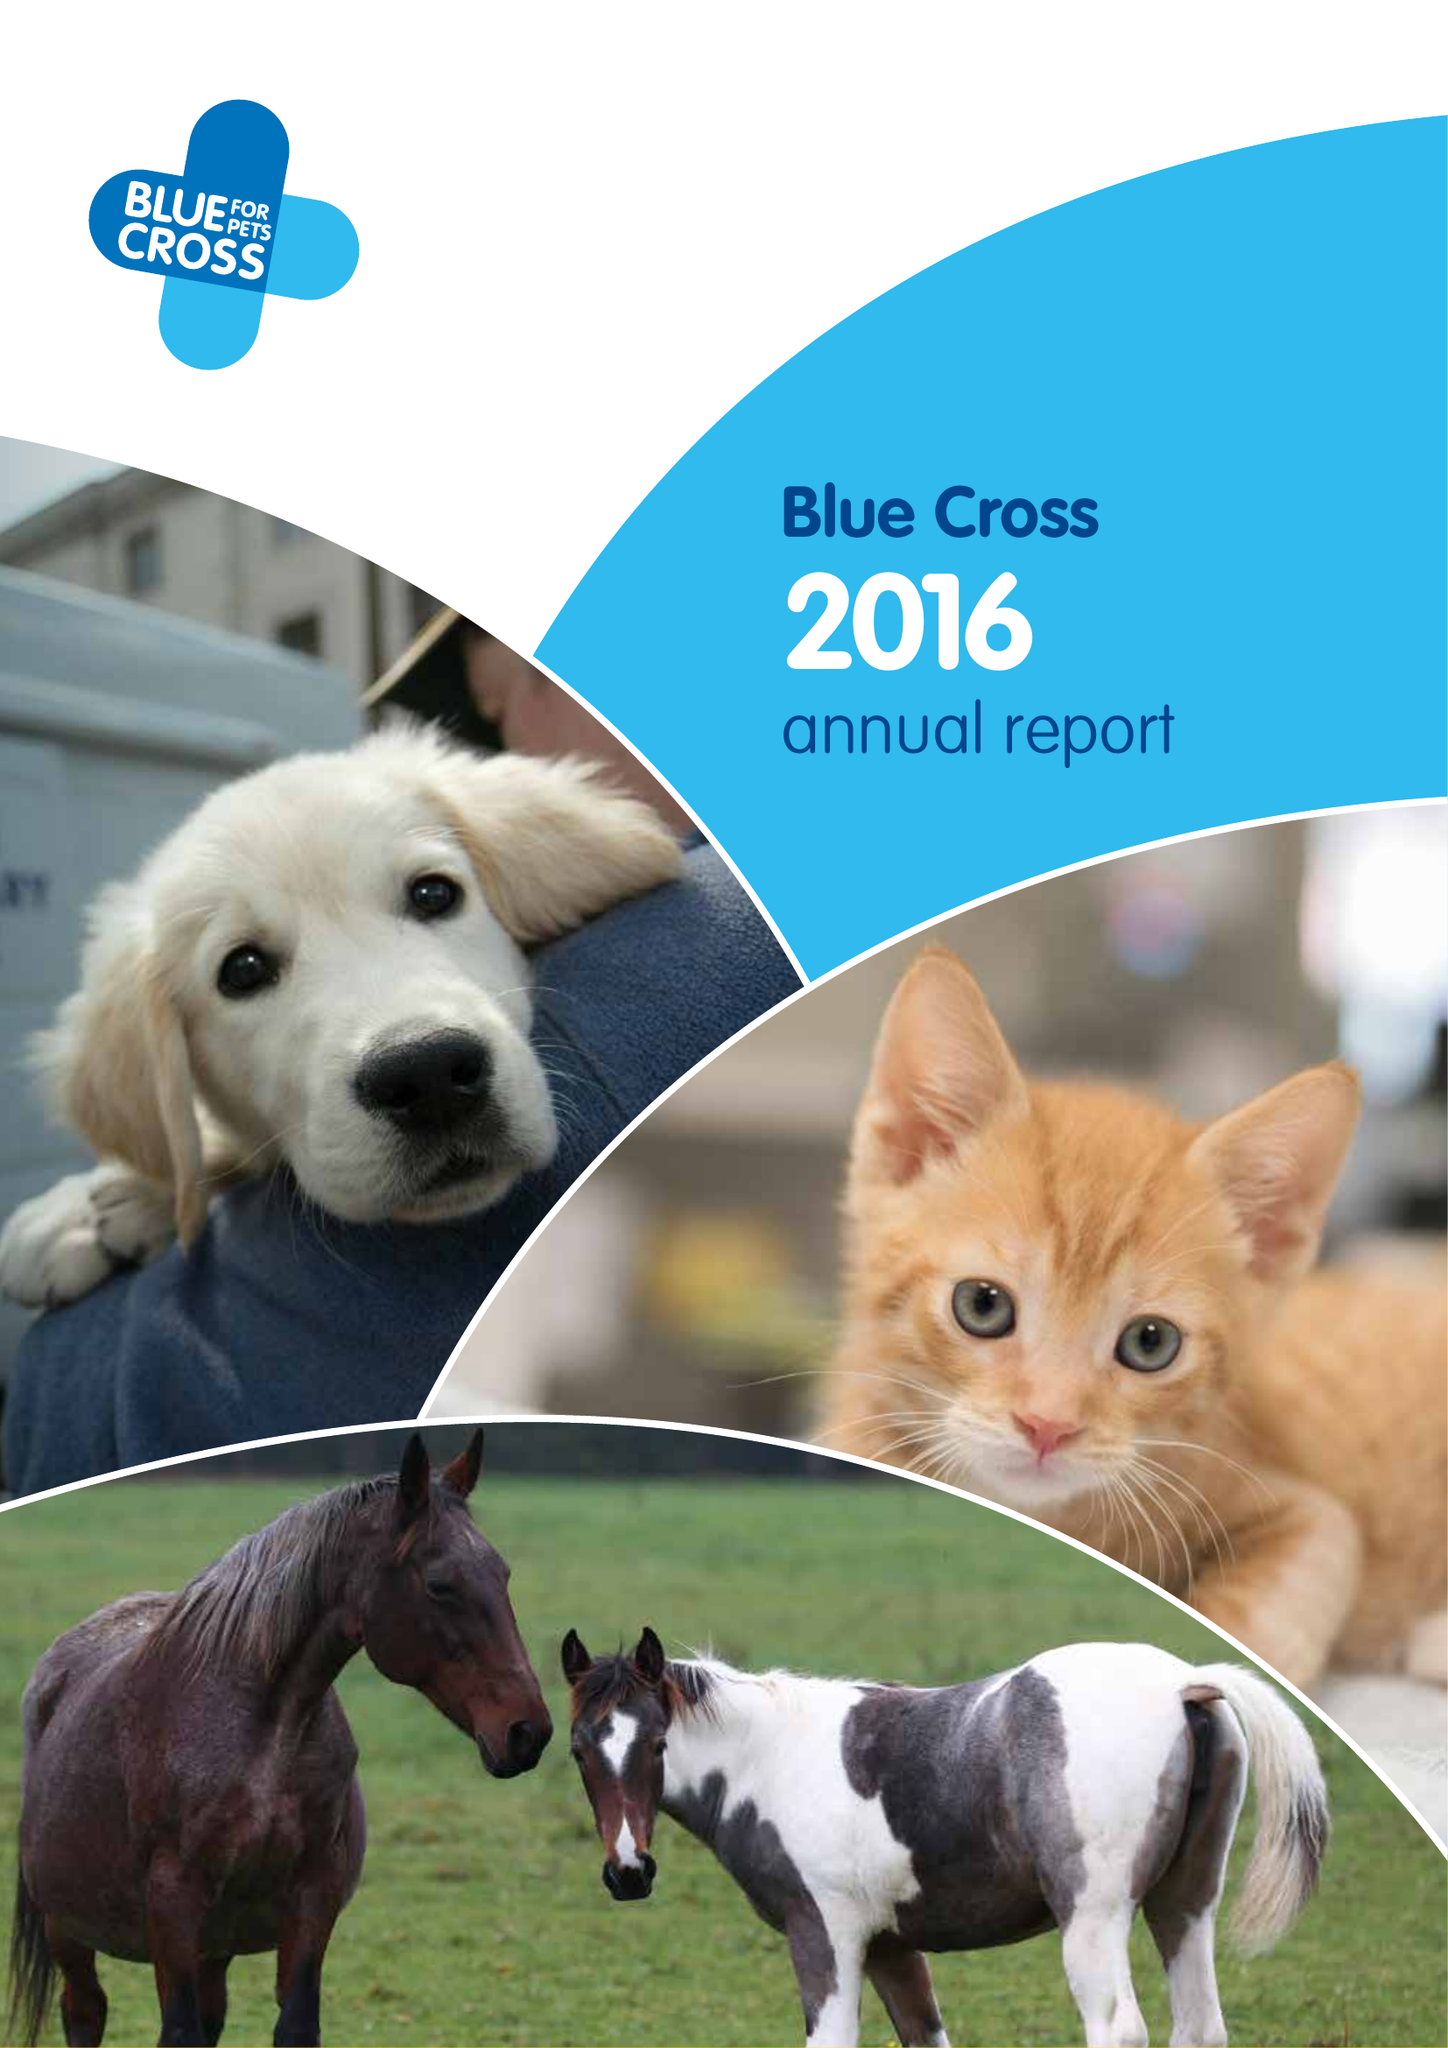What is the value for the charity_name?
Answer the question using a single word or phrase. Blue Cross 